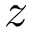Convert formula to latex. <formula><loc_0><loc_0><loc_500><loc_500>z</formula> 